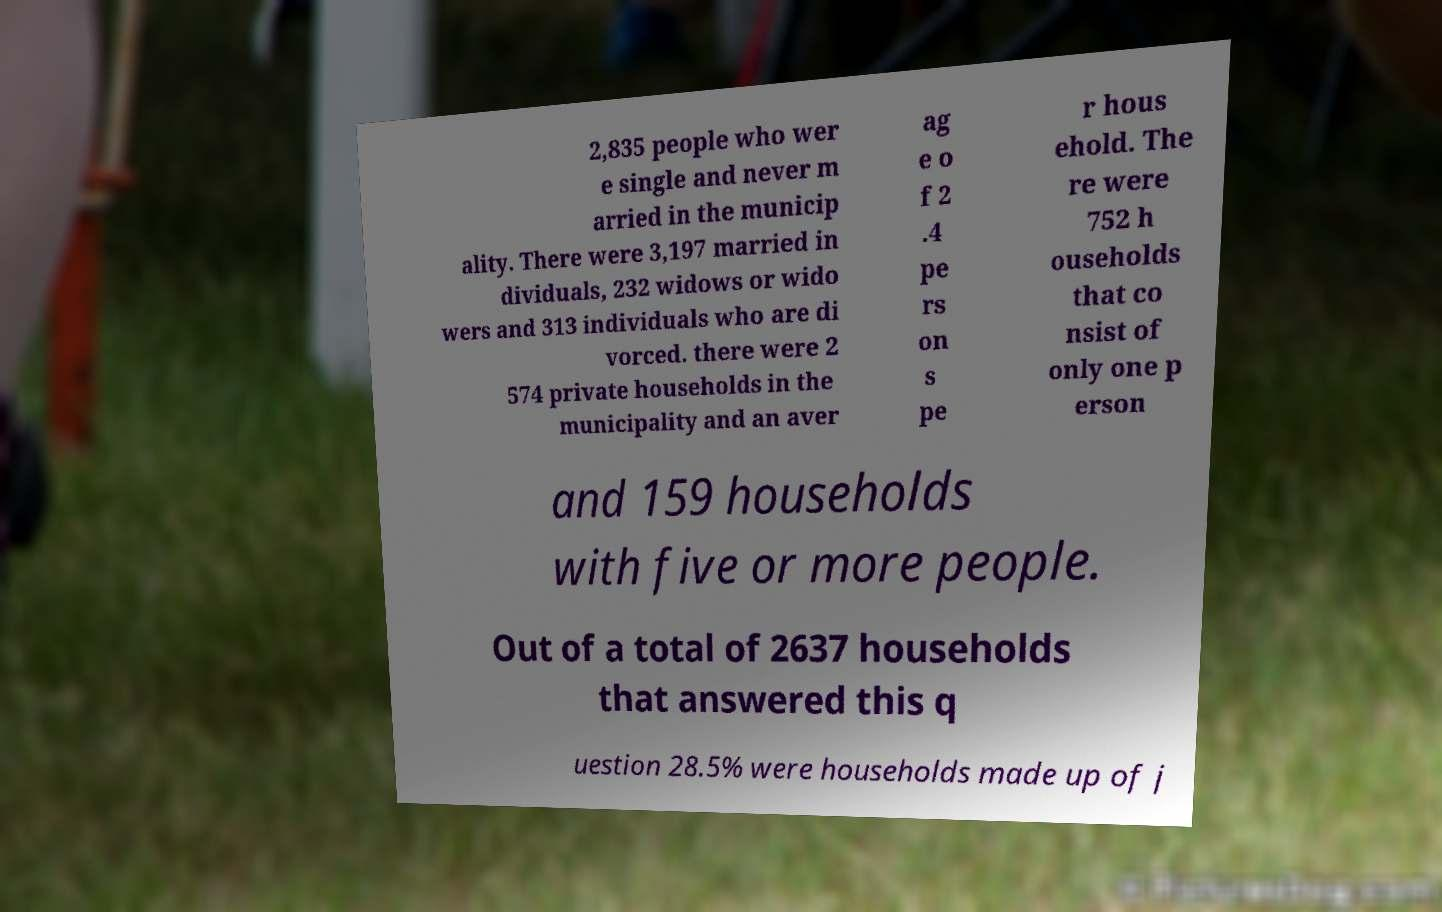What messages or text are displayed in this image? I need them in a readable, typed format. 2,835 people who wer e single and never m arried in the municip ality. There were 3,197 married in dividuals, 232 widows or wido wers and 313 individuals who are di vorced. there were 2 574 private households in the municipality and an aver ag e o f 2 .4 pe rs on s pe r hous ehold. The re were 752 h ouseholds that co nsist of only one p erson and 159 households with five or more people. Out of a total of 2637 households that answered this q uestion 28.5% were households made up of j 